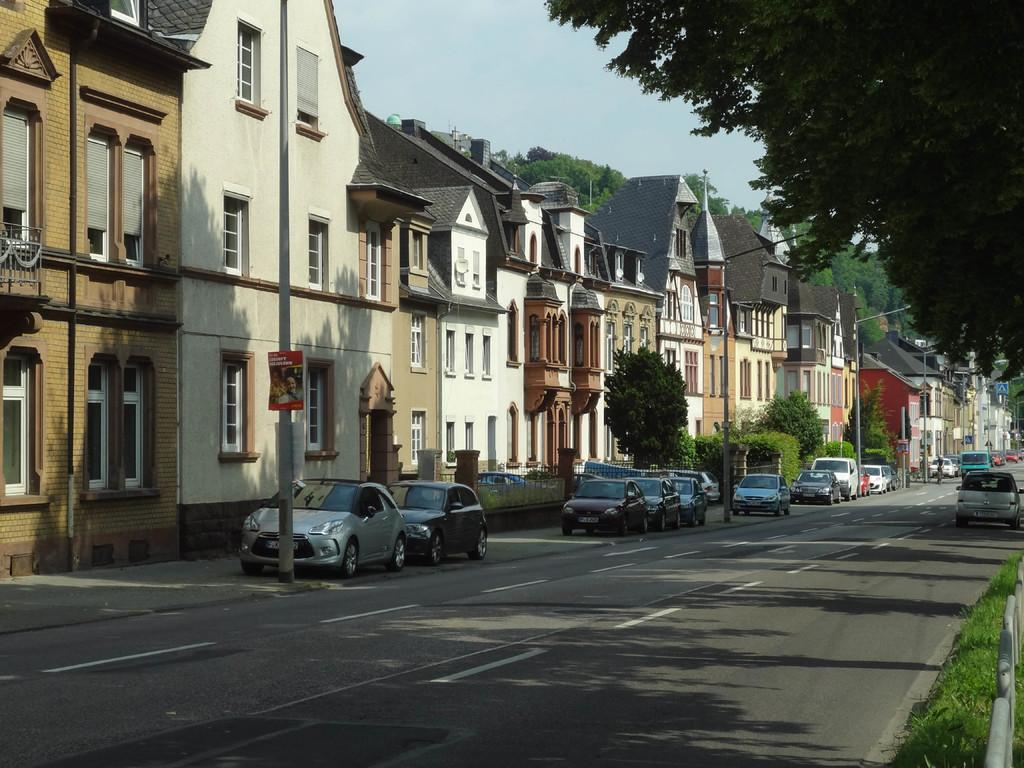What type of vegetation is present in the image? There is grass in the image. What structures can be seen in the image? There are fences, buildings, and boards on poles in the image. What type of transportation is visible in the image? There are vehicles on the road in the image. What other natural elements are present in the image? There are trees in the image. What else can be seen on the poles besides the boards? There are poles in the image. What part of the natural environment is visible in the image? The sky is visible in the image. How many taxes are being paid by the trees in the image? There are no taxes mentioned or implied in the image, and trees do not pay taxes. What type of bead is being used to decorate the grass in the image? There are no beads present in the image, and beads are not used to decorate grass. 